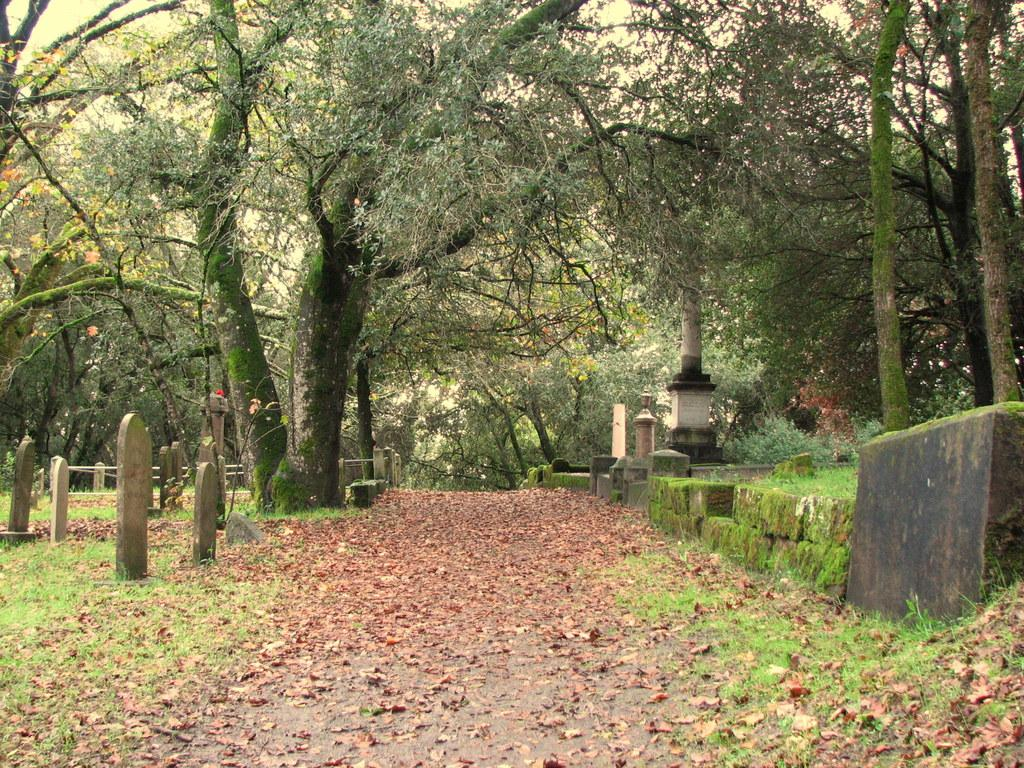What type of natural material is present on the road in the image? There are dried leaves on the road. What type of vegetation is present on the ground in the image? There is grass on the ground. How many trees can be seen in the image? There are many trees visible in the image. What type of structures are present in the image? There are graves visible in the image. What architectural feature can be seen in the background of the image? There is a railing in the background. Can you tell me the relation between the rose and the glove in the image? There is no rose or glove present in the image. 